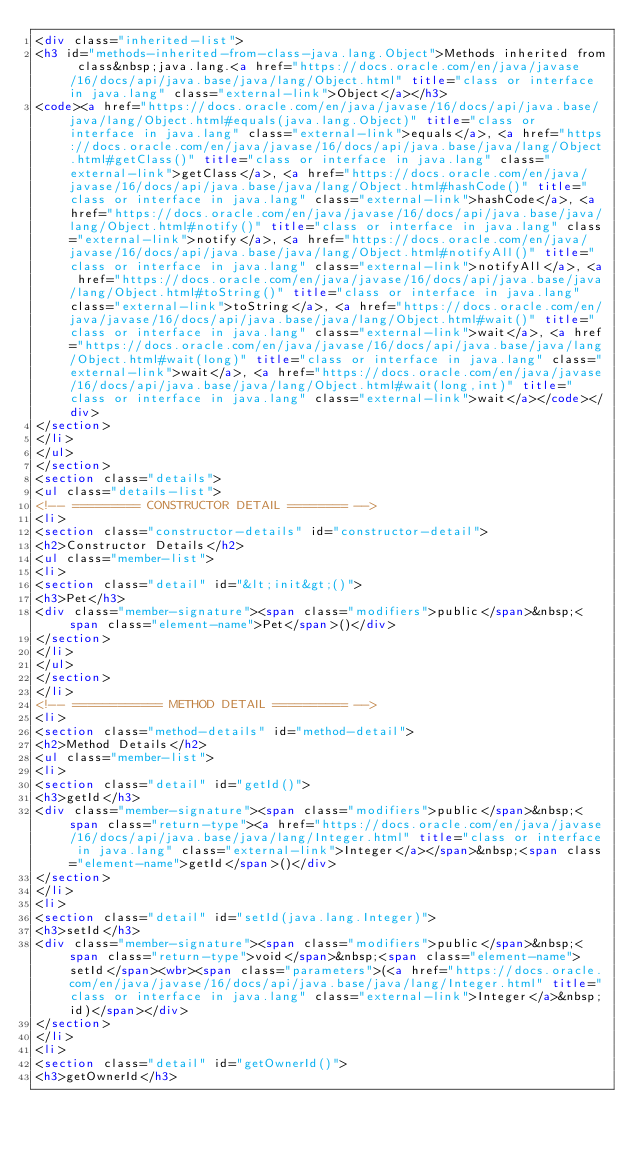Convert code to text. <code><loc_0><loc_0><loc_500><loc_500><_HTML_><div class="inherited-list">
<h3 id="methods-inherited-from-class-java.lang.Object">Methods inherited from class&nbsp;java.lang.<a href="https://docs.oracle.com/en/java/javase/16/docs/api/java.base/java/lang/Object.html" title="class or interface in java.lang" class="external-link">Object</a></h3>
<code><a href="https://docs.oracle.com/en/java/javase/16/docs/api/java.base/java/lang/Object.html#equals(java.lang.Object)" title="class or interface in java.lang" class="external-link">equals</a>, <a href="https://docs.oracle.com/en/java/javase/16/docs/api/java.base/java/lang/Object.html#getClass()" title="class or interface in java.lang" class="external-link">getClass</a>, <a href="https://docs.oracle.com/en/java/javase/16/docs/api/java.base/java/lang/Object.html#hashCode()" title="class or interface in java.lang" class="external-link">hashCode</a>, <a href="https://docs.oracle.com/en/java/javase/16/docs/api/java.base/java/lang/Object.html#notify()" title="class or interface in java.lang" class="external-link">notify</a>, <a href="https://docs.oracle.com/en/java/javase/16/docs/api/java.base/java/lang/Object.html#notifyAll()" title="class or interface in java.lang" class="external-link">notifyAll</a>, <a href="https://docs.oracle.com/en/java/javase/16/docs/api/java.base/java/lang/Object.html#toString()" title="class or interface in java.lang" class="external-link">toString</a>, <a href="https://docs.oracle.com/en/java/javase/16/docs/api/java.base/java/lang/Object.html#wait()" title="class or interface in java.lang" class="external-link">wait</a>, <a href="https://docs.oracle.com/en/java/javase/16/docs/api/java.base/java/lang/Object.html#wait(long)" title="class or interface in java.lang" class="external-link">wait</a>, <a href="https://docs.oracle.com/en/java/javase/16/docs/api/java.base/java/lang/Object.html#wait(long,int)" title="class or interface in java.lang" class="external-link">wait</a></code></div>
</section>
</li>
</ul>
</section>
<section class="details">
<ul class="details-list">
<!-- ========= CONSTRUCTOR DETAIL ======== -->
<li>
<section class="constructor-details" id="constructor-detail">
<h2>Constructor Details</h2>
<ul class="member-list">
<li>
<section class="detail" id="&lt;init&gt;()">
<h3>Pet</h3>
<div class="member-signature"><span class="modifiers">public</span>&nbsp;<span class="element-name">Pet</span>()</div>
</section>
</li>
</ul>
</section>
</li>
<!-- ============ METHOD DETAIL ========== -->
<li>
<section class="method-details" id="method-detail">
<h2>Method Details</h2>
<ul class="member-list">
<li>
<section class="detail" id="getId()">
<h3>getId</h3>
<div class="member-signature"><span class="modifiers">public</span>&nbsp;<span class="return-type"><a href="https://docs.oracle.com/en/java/javase/16/docs/api/java.base/java/lang/Integer.html" title="class or interface in java.lang" class="external-link">Integer</a></span>&nbsp;<span class="element-name">getId</span>()</div>
</section>
</li>
<li>
<section class="detail" id="setId(java.lang.Integer)">
<h3>setId</h3>
<div class="member-signature"><span class="modifiers">public</span>&nbsp;<span class="return-type">void</span>&nbsp;<span class="element-name">setId</span><wbr><span class="parameters">(<a href="https://docs.oracle.com/en/java/javase/16/docs/api/java.base/java/lang/Integer.html" title="class or interface in java.lang" class="external-link">Integer</a>&nbsp;id)</span></div>
</section>
</li>
<li>
<section class="detail" id="getOwnerId()">
<h3>getOwnerId</h3></code> 